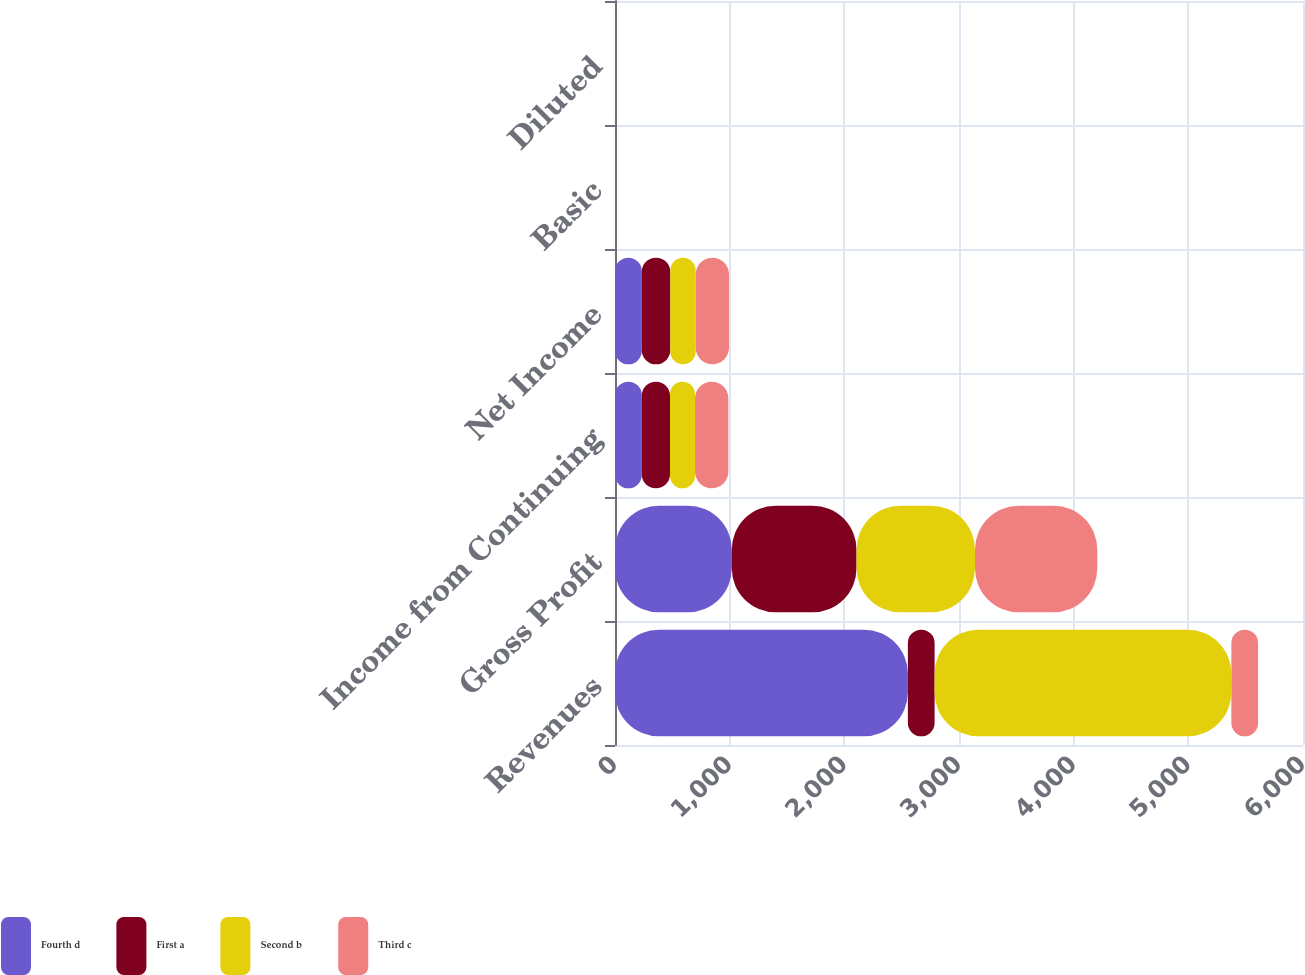Convert chart. <chart><loc_0><loc_0><loc_500><loc_500><stacked_bar_chart><ecel><fcel>Revenues<fcel>Gross Profit<fcel>Income from Continuing<fcel>Net Income<fcel>Basic<fcel>Diluted<nl><fcel>Fourth d<fcel>2554<fcel>1018.4<fcel>233.4<fcel>233<fcel>0.56<fcel>0.54<nl><fcel>First a<fcel>233.2<fcel>1088.1<fcel>246.3<fcel>249.5<fcel>0.59<fcel>0.56<nl><fcel>Second b<fcel>2588.1<fcel>1032.8<fcel>218.3<fcel>221.5<fcel>0.52<fcel>0.5<nl><fcel>Third c<fcel>233.2<fcel>1066.9<fcel>290.7<fcel>290.2<fcel>0.69<fcel>0.68<nl></chart> 